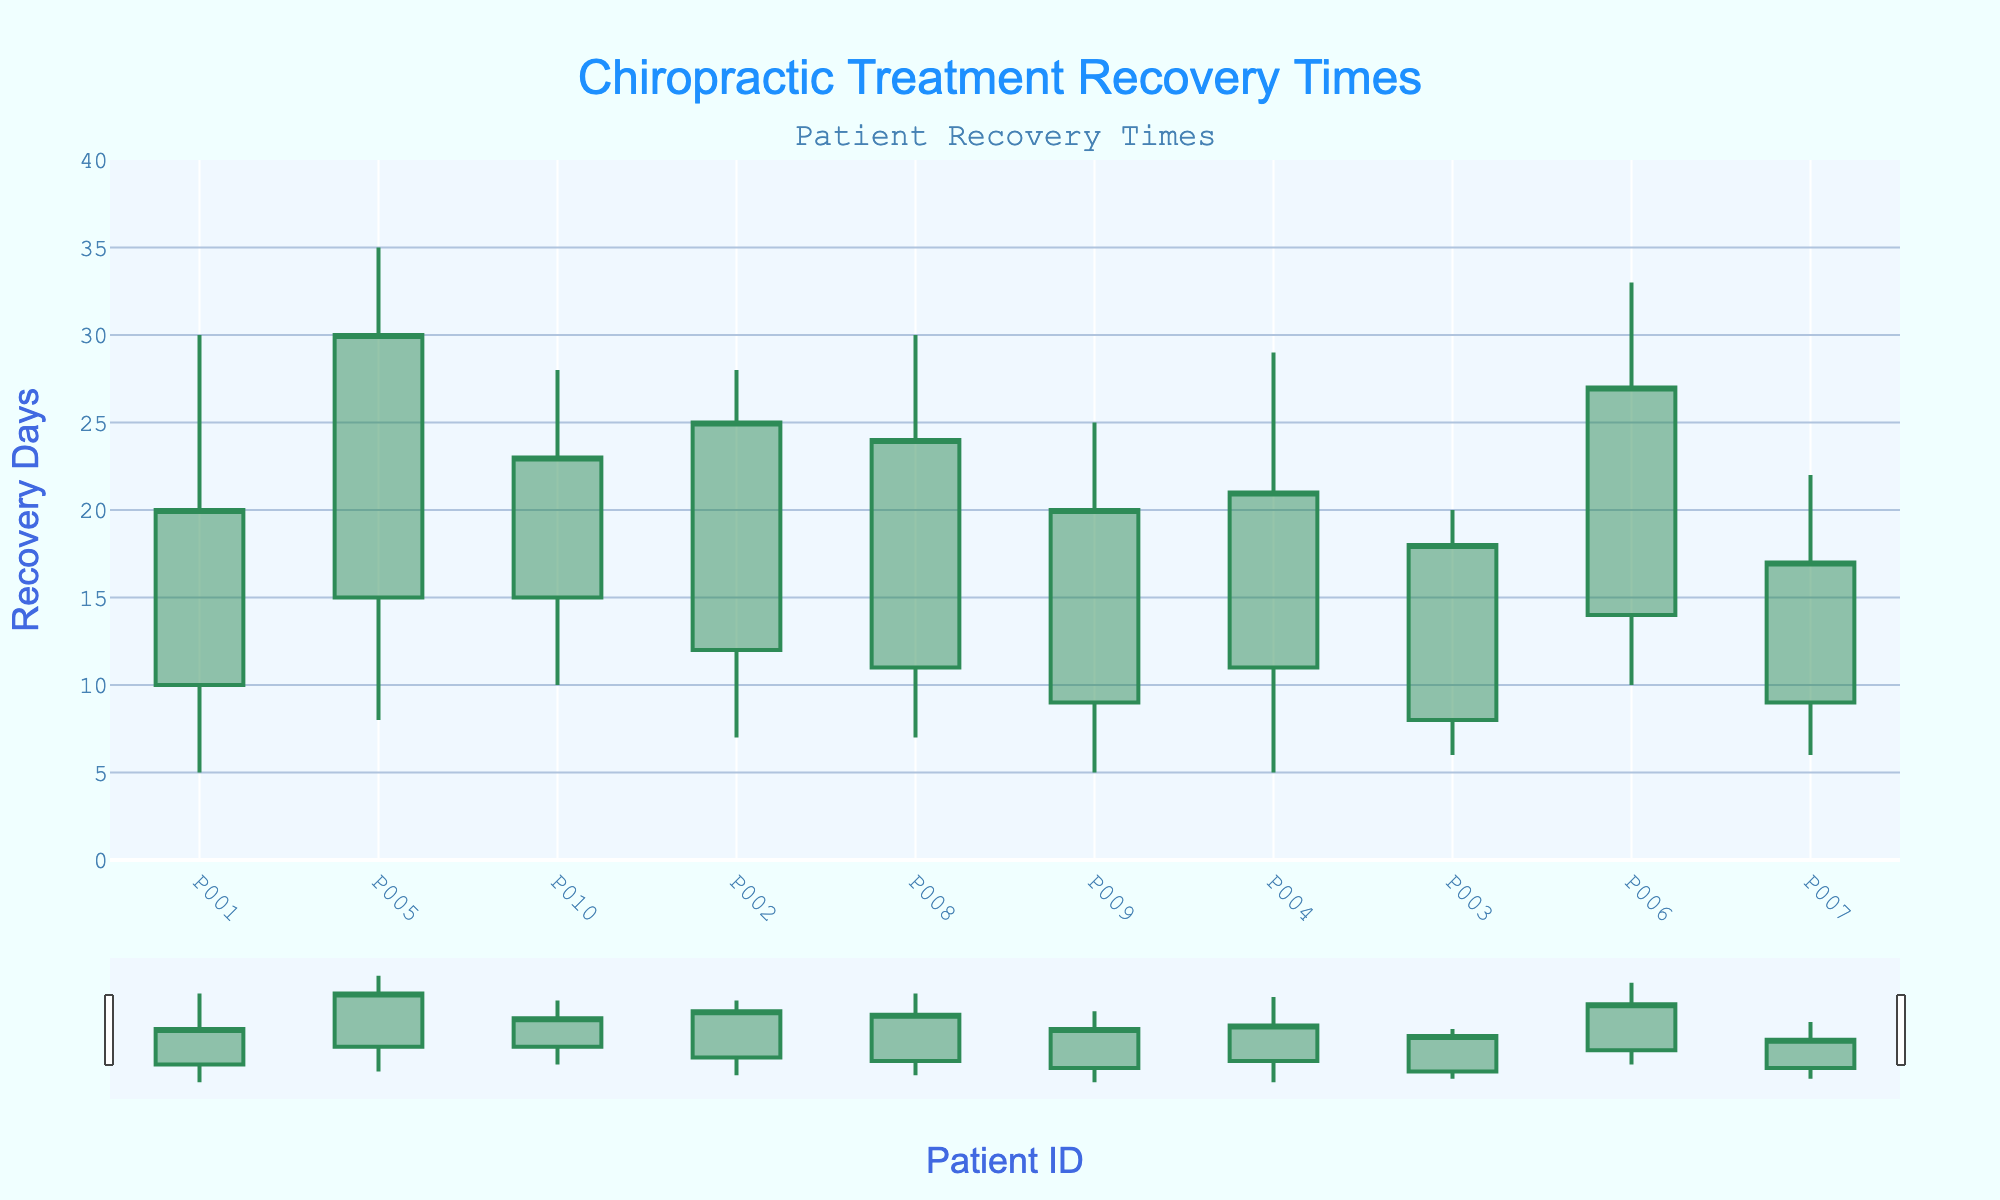What's the title of the plot? The title of the plot is displayed at the top of the figure. In this case, it reads "Chiropractic Treatment Recovery Times".
Answer: Chiropractic Treatment Recovery Times What is the color of the increasing and decreasing lines respectively? The color of the increasing lines is labeled as sea green, and the decreasing lines are saddle brown.
Answer: Sea Green and Saddle Brown How many patients are represented in the figure? Each patient's ID represents a data point on the x-axis. Counting the number of unique Patient IDs gives the total number of patients. There are 10 Patient IDs listed.
Answer: 10 Which patient experienced the longest high recovery time? By looking at the length of the "high" part of the candlestick bars, we see that patient P005 has the highest recovery time of 35 days.
Answer: P005 Which patient experienced the shortest low recovery time? By observing the "low" part of the candlesticks, patient P001 and P004 both experienced the shortest low recovery time of 5 days.
Answer: P001 and P004 What is the difference in the closing recovery days between the patients with the highest and lowest closing recovery days? Identify the highest close recovery day, which is 30 days for P005, and the lowest, which is 17 days for P007. The difference is 30 - 17 = 13 days.
Answer: 13 days On average, how many days does recovery start (open recovery days) across all patients? Sum the open recovery days and divide by the number of patients: (10 + 12 + 8 + 11 + 15 + 14 + 9 + 11 + 9 + 15) / 10 = 114 / 10 = 11.4 days.
Answer: 11.4 days Which patient shows the largest range in recovery time? The range is calculated by subtracting the "low recovery days" from the "high recovery days" for each patient. Patient P005 has the largest range: 35 - 8 = 27 days.
Answer: P005 Are there any patients whose recovery times (open vs. close) decreased over the treatment period? The recovery days decreased if the "open recovery days" are greater than the "close recovery days". By comparing these values, patients P001, P003, P007, and P010 had a decrease in recovery days.
Answer: P001, P003, P007, and P010 What is the median high recovery time among all patients? Listing all high recovery times: 20, 22, 25, 28, 28, 29, 30, 30, 33, 35, the median value is the average of the 5th and 6th highest, which is (28 + 28) / 2 = 28 days.
Answer: 28 days 